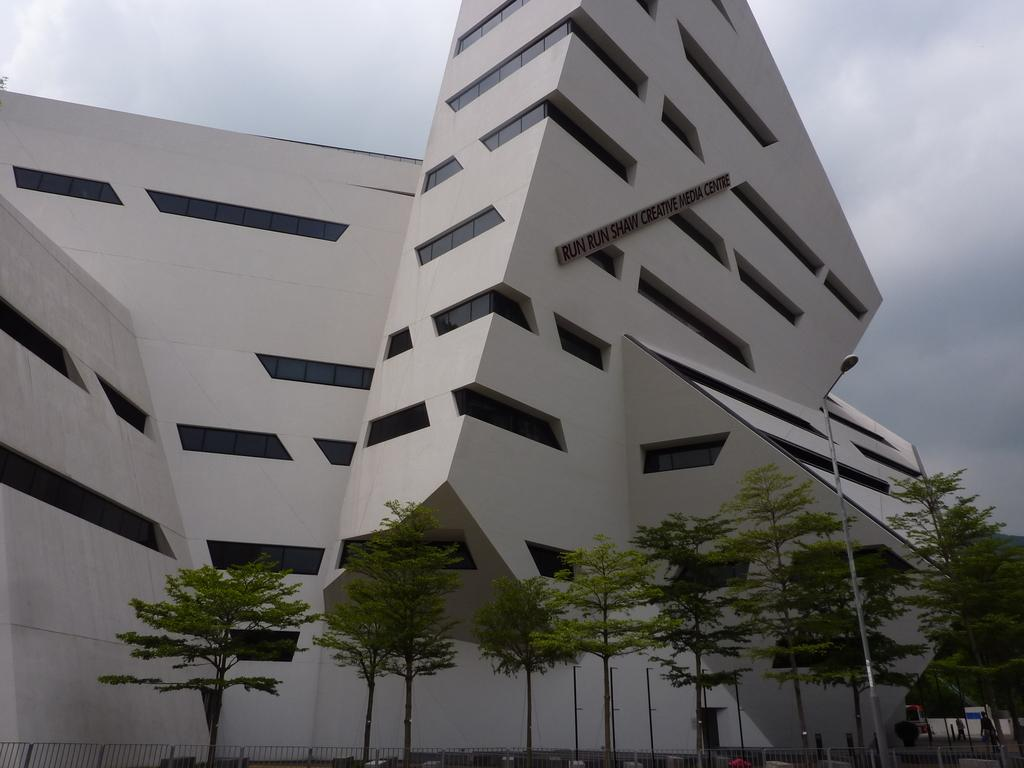What type of structure is visible in the image? There is a building in the image. What can be seen in front of the building? There are trees, a railing, a pole, and a streetlight in front of the building. Can you describe the railing in front of the building? The railing is a barrier or boundary in front of the building. What is the purpose of the pole in front of the building? The pole might be used for supporting a sign, a light, or other objects. How many berries are on the pole in the image? There are no berries present in the image, as the pole is likely used for supporting a sign or a light. 